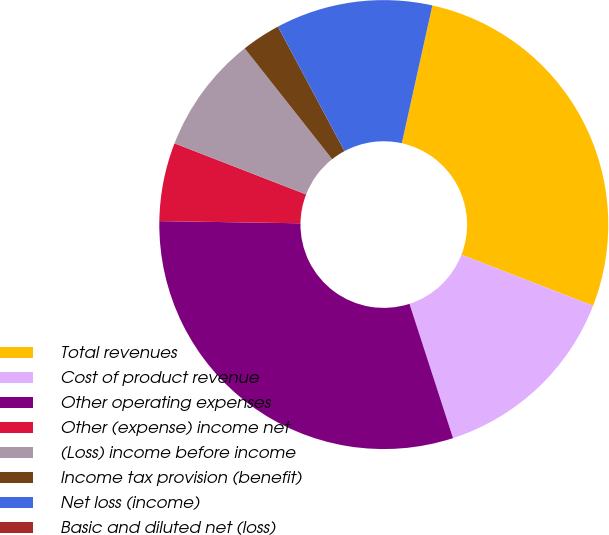Convert chart to OTSL. <chart><loc_0><loc_0><loc_500><loc_500><pie_chart><fcel>Total revenues<fcel>Cost of product revenue<fcel>Other operating expenses<fcel>Other (expense) income net<fcel>(Loss) income before income<fcel>Income tax provision (benefit)<fcel>Net loss (income)<fcel>Basic and diluted net (loss)<nl><fcel>27.42%<fcel>14.12%<fcel>30.24%<fcel>5.65%<fcel>8.47%<fcel>2.82%<fcel>11.29%<fcel>0.0%<nl></chart> 